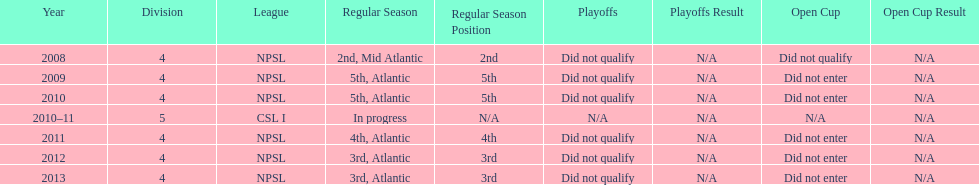How did they place the year after they were 4th in the regular season? 3rd. 